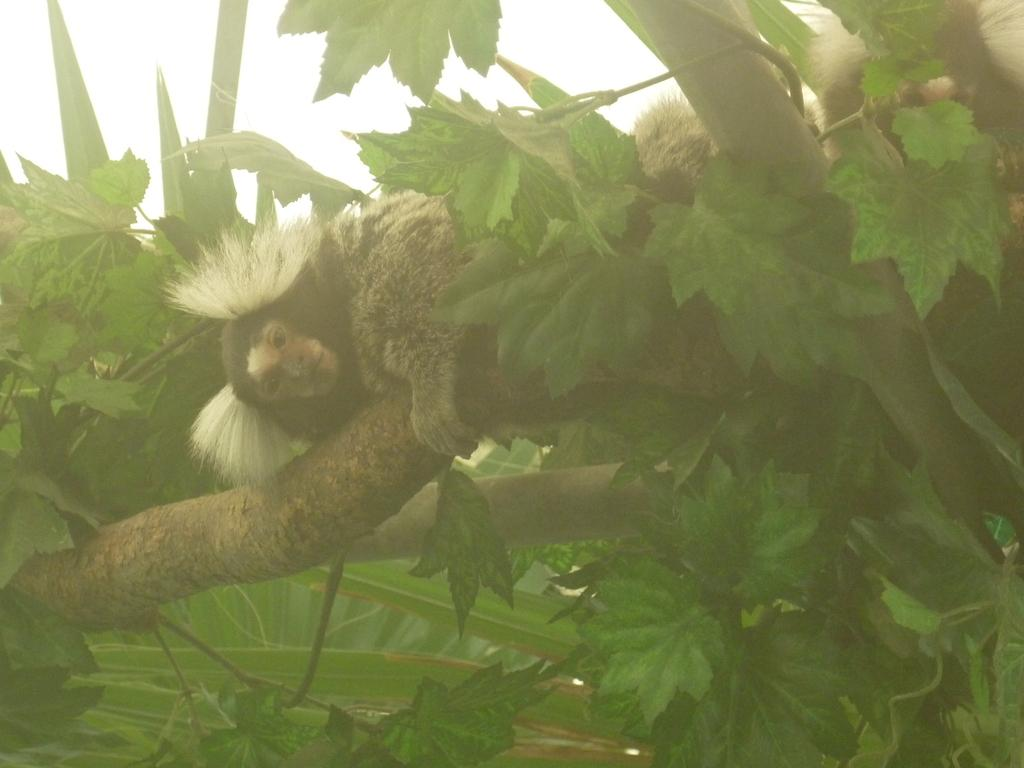What is on the tree in the image? There is an animal on the tree in the image. What can be seen in the background of the image? The sky is visible in the background of the image. Where is the cave located in the image? There is no cave present in the image. What is the afterthought of the animal in the image? The image does not convey any afterthoughts or emotions of the animal; it simply shows the animal on the tree. What is the animal teaching in the image? The image does not depict the animal teaching anything; it only shows the animal on the tree. 